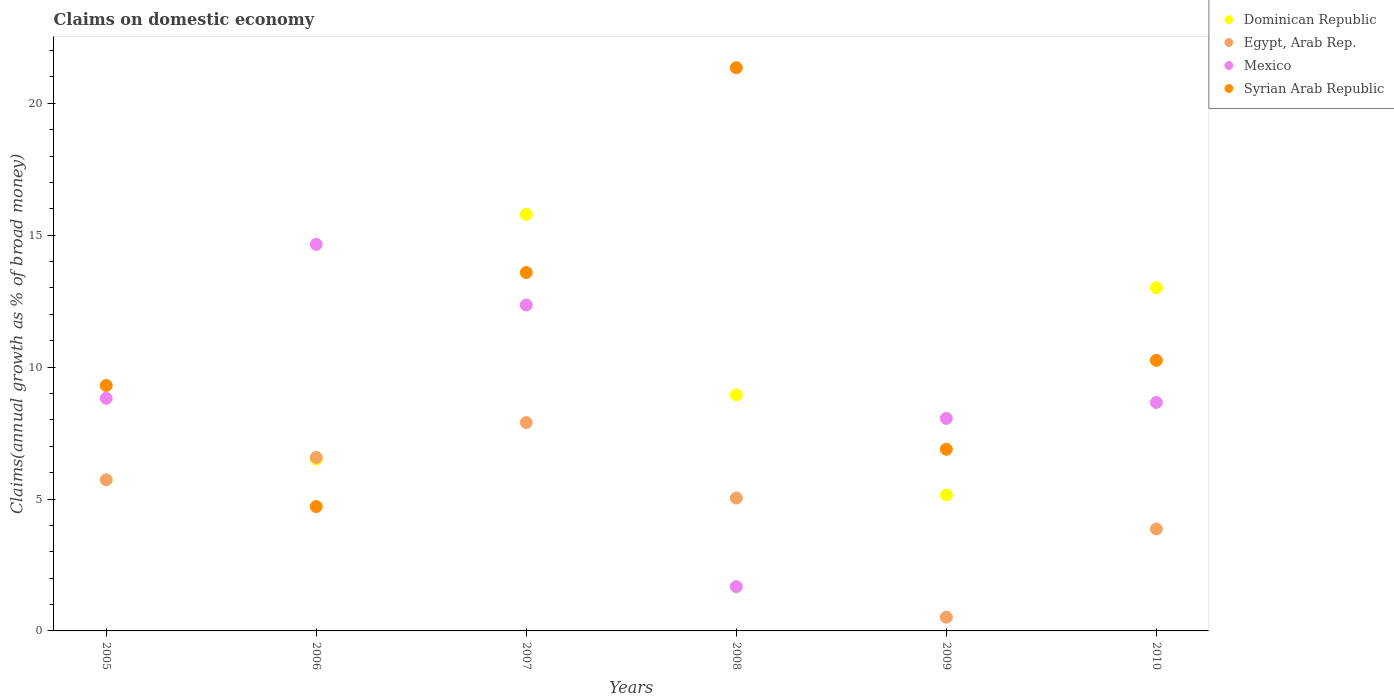What is the percentage of broad money claimed on domestic economy in Syrian Arab Republic in 2009?
Offer a terse response. 6.89. Across all years, what is the maximum percentage of broad money claimed on domestic economy in Egypt, Arab Rep.?
Provide a short and direct response. 7.9. Across all years, what is the minimum percentage of broad money claimed on domestic economy in Syrian Arab Republic?
Your answer should be very brief. 4.71. What is the total percentage of broad money claimed on domestic economy in Syrian Arab Republic in the graph?
Provide a short and direct response. 66.1. What is the difference between the percentage of broad money claimed on domestic economy in Syrian Arab Republic in 2007 and that in 2009?
Provide a short and direct response. 6.7. What is the difference between the percentage of broad money claimed on domestic economy in Syrian Arab Republic in 2006 and the percentage of broad money claimed on domestic economy in Mexico in 2007?
Your answer should be very brief. -7.64. What is the average percentage of broad money claimed on domestic economy in Syrian Arab Republic per year?
Give a very brief answer. 11.02. In the year 2007, what is the difference between the percentage of broad money claimed on domestic economy in Mexico and percentage of broad money claimed on domestic economy in Syrian Arab Republic?
Provide a succinct answer. -1.23. What is the ratio of the percentage of broad money claimed on domestic economy in Syrian Arab Republic in 2007 to that in 2008?
Your answer should be compact. 0.64. Is the percentage of broad money claimed on domestic economy in Mexico in 2005 less than that in 2008?
Give a very brief answer. No. Is the difference between the percentage of broad money claimed on domestic economy in Mexico in 2005 and 2006 greater than the difference between the percentage of broad money claimed on domestic economy in Syrian Arab Republic in 2005 and 2006?
Provide a short and direct response. No. What is the difference between the highest and the second highest percentage of broad money claimed on domestic economy in Mexico?
Make the answer very short. 2.3. What is the difference between the highest and the lowest percentage of broad money claimed on domestic economy in Egypt, Arab Rep.?
Provide a short and direct response. 7.38. In how many years, is the percentage of broad money claimed on domestic economy in Syrian Arab Republic greater than the average percentage of broad money claimed on domestic economy in Syrian Arab Republic taken over all years?
Your answer should be very brief. 2. Are the values on the major ticks of Y-axis written in scientific E-notation?
Offer a terse response. No. Does the graph contain any zero values?
Offer a very short reply. Yes. Does the graph contain grids?
Make the answer very short. No. Where does the legend appear in the graph?
Provide a succinct answer. Top right. What is the title of the graph?
Provide a succinct answer. Claims on domestic economy. What is the label or title of the Y-axis?
Make the answer very short. Claims(annual growth as % of broad money). What is the Claims(annual growth as % of broad money) of Egypt, Arab Rep. in 2005?
Make the answer very short. 5.73. What is the Claims(annual growth as % of broad money) of Mexico in 2005?
Offer a terse response. 8.82. What is the Claims(annual growth as % of broad money) in Syrian Arab Republic in 2005?
Your answer should be very brief. 9.3. What is the Claims(annual growth as % of broad money) in Dominican Republic in 2006?
Your response must be concise. 6.51. What is the Claims(annual growth as % of broad money) of Egypt, Arab Rep. in 2006?
Give a very brief answer. 6.58. What is the Claims(annual growth as % of broad money) of Mexico in 2006?
Provide a succinct answer. 14.65. What is the Claims(annual growth as % of broad money) in Syrian Arab Republic in 2006?
Your answer should be very brief. 4.71. What is the Claims(annual growth as % of broad money) of Dominican Republic in 2007?
Make the answer very short. 15.79. What is the Claims(annual growth as % of broad money) in Egypt, Arab Rep. in 2007?
Provide a short and direct response. 7.9. What is the Claims(annual growth as % of broad money) in Mexico in 2007?
Your answer should be compact. 12.35. What is the Claims(annual growth as % of broad money) in Syrian Arab Republic in 2007?
Provide a short and direct response. 13.59. What is the Claims(annual growth as % of broad money) of Dominican Republic in 2008?
Your answer should be very brief. 8.95. What is the Claims(annual growth as % of broad money) in Egypt, Arab Rep. in 2008?
Provide a succinct answer. 5.04. What is the Claims(annual growth as % of broad money) of Mexico in 2008?
Your response must be concise. 1.68. What is the Claims(annual growth as % of broad money) in Syrian Arab Republic in 2008?
Make the answer very short. 21.35. What is the Claims(annual growth as % of broad money) in Dominican Republic in 2009?
Your response must be concise. 5.15. What is the Claims(annual growth as % of broad money) of Egypt, Arab Rep. in 2009?
Your response must be concise. 0.52. What is the Claims(annual growth as % of broad money) in Mexico in 2009?
Give a very brief answer. 8.06. What is the Claims(annual growth as % of broad money) of Syrian Arab Republic in 2009?
Give a very brief answer. 6.89. What is the Claims(annual growth as % of broad money) in Dominican Republic in 2010?
Provide a short and direct response. 13.01. What is the Claims(annual growth as % of broad money) in Egypt, Arab Rep. in 2010?
Offer a terse response. 3.87. What is the Claims(annual growth as % of broad money) in Mexico in 2010?
Offer a very short reply. 8.66. What is the Claims(annual growth as % of broad money) in Syrian Arab Republic in 2010?
Keep it short and to the point. 10.26. Across all years, what is the maximum Claims(annual growth as % of broad money) in Dominican Republic?
Keep it short and to the point. 15.79. Across all years, what is the maximum Claims(annual growth as % of broad money) in Egypt, Arab Rep.?
Give a very brief answer. 7.9. Across all years, what is the maximum Claims(annual growth as % of broad money) in Mexico?
Give a very brief answer. 14.65. Across all years, what is the maximum Claims(annual growth as % of broad money) of Syrian Arab Republic?
Provide a short and direct response. 21.35. Across all years, what is the minimum Claims(annual growth as % of broad money) of Dominican Republic?
Offer a very short reply. 0. Across all years, what is the minimum Claims(annual growth as % of broad money) in Egypt, Arab Rep.?
Your answer should be very brief. 0.52. Across all years, what is the minimum Claims(annual growth as % of broad money) of Mexico?
Your answer should be very brief. 1.68. Across all years, what is the minimum Claims(annual growth as % of broad money) in Syrian Arab Republic?
Keep it short and to the point. 4.71. What is the total Claims(annual growth as % of broad money) of Dominican Republic in the graph?
Your response must be concise. 49.41. What is the total Claims(annual growth as % of broad money) in Egypt, Arab Rep. in the graph?
Your answer should be compact. 29.63. What is the total Claims(annual growth as % of broad money) of Mexico in the graph?
Offer a very short reply. 54.22. What is the total Claims(annual growth as % of broad money) of Syrian Arab Republic in the graph?
Offer a very short reply. 66.1. What is the difference between the Claims(annual growth as % of broad money) of Egypt, Arab Rep. in 2005 and that in 2006?
Give a very brief answer. -0.85. What is the difference between the Claims(annual growth as % of broad money) of Mexico in 2005 and that in 2006?
Your response must be concise. -5.83. What is the difference between the Claims(annual growth as % of broad money) of Syrian Arab Republic in 2005 and that in 2006?
Provide a short and direct response. 4.59. What is the difference between the Claims(annual growth as % of broad money) in Egypt, Arab Rep. in 2005 and that in 2007?
Offer a terse response. -2.17. What is the difference between the Claims(annual growth as % of broad money) of Mexico in 2005 and that in 2007?
Give a very brief answer. -3.54. What is the difference between the Claims(annual growth as % of broad money) of Syrian Arab Republic in 2005 and that in 2007?
Offer a very short reply. -4.28. What is the difference between the Claims(annual growth as % of broad money) in Egypt, Arab Rep. in 2005 and that in 2008?
Your answer should be very brief. 0.69. What is the difference between the Claims(annual growth as % of broad money) of Mexico in 2005 and that in 2008?
Ensure brevity in your answer.  7.14. What is the difference between the Claims(annual growth as % of broad money) of Syrian Arab Republic in 2005 and that in 2008?
Ensure brevity in your answer.  -12.05. What is the difference between the Claims(annual growth as % of broad money) of Egypt, Arab Rep. in 2005 and that in 2009?
Give a very brief answer. 5.21. What is the difference between the Claims(annual growth as % of broad money) of Mexico in 2005 and that in 2009?
Keep it short and to the point. 0.76. What is the difference between the Claims(annual growth as % of broad money) of Syrian Arab Republic in 2005 and that in 2009?
Your answer should be compact. 2.42. What is the difference between the Claims(annual growth as % of broad money) of Egypt, Arab Rep. in 2005 and that in 2010?
Offer a terse response. 1.86. What is the difference between the Claims(annual growth as % of broad money) in Mexico in 2005 and that in 2010?
Offer a terse response. 0.16. What is the difference between the Claims(annual growth as % of broad money) of Syrian Arab Republic in 2005 and that in 2010?
Make the answer very short. -0.95. What is the difference between the Claims(annual growth as % of broad money) of Dominican Republic in 2006 and that in 2007?
Provide a short and direct response. -9.28. What is the difference between the Claims(annual growth as % of broad money) of Egypt, Arab Rep. in 2006 and that in 2007?
Provide a short and direct response. -1.32. What is the difference between the Claims(annual growth as % of broad money) in Mexico in 2006 and that in 2007?
Make the answer very short. 2.3. What is the difference between the Claims(annual growth as % of broad money) of Syrian Arab Republic in 2006 and that in 2007?
Your answer should be compact. -8.87. What is the difference between the Claims(annual growth as % of broad money) of Dominican Republic in 2006 and that in 2008?
Give a very brief answer. -2.44. What is the difference between the Claims(annual growth as % of broad money) of Egypt, Arab Rep. in 2006 and that in 2008?
Give a very brief answer. 1.54. What is the difference between the Claims(annual growth as % of broad money) of Mexico in 2006 and that in 2008?
Give a very brief answer. 12.97. What is the difference between the Claims(annual growth as % of broad money) of Syrian Arab Republic in 2006 and that in 2008?
Your response must be concise. -16.64. What is the difference between the Claims(annual growth as % of broad money) of Dominican Republic in 2006 and that in 2009?
Your answer should be compact. 1.36. What is the difference between the Claims(annual growth as % of broad money) of Egypt, Arab Rep. in 2006 and that in 2009?
Provide a succinct answer. 6.06. What is the difference between the Claims(annual growth as % of broad money) in Mexico in 2006 and that in 2009?
Ensure brevity in your answer.  6.59. What is the difference between the Claims(annual growth as % of broad money) in Syrian Arab Republic in 2006 and that in 2009?
Provide a succinct answer. -2.17. What is the difference between the Claims(annual growth as % of broad money) in Dominican Republic in 2006 and that in 2010?
Provide a short and direct response. -6.5. What is the difference between the Claims(annual growth as % of broad money) in Egypt, Arab Rep. in 2006 and that in 2010?
Your answer should be compact. 2.71. What is the difference between the Claims(annual growth as % of broad money) of Mexico in 2006 and that in 2010?
Your answer should be compact. 5.99. What is the difference between the Claims(annual growth as % of broad money) of Syrian Arab Republic in 2006 and that in 2010?
Make the answer very short. -5.54. What is the difference between the Claims(annual growth as % of broad money) of Dominican Republic in 2007 and that in 2008?
Offer a terse response. 6.84. What is the difference between the Claims(annual growth as % of broad money) in Egypt, Arab Rep. in 2007 and that in 2008?
Provide a short and direct response. 2.86. What is the difference between the Claims(annual growth as % of broad money) in Mexico in 2007 and that in 2008?
Your answer should be compact. 10.67. What is the difference between the Claims(annual growth as % of broad money) of Syrian Arab Republic in 2007 and that in 2008?
Provide a succinct answer. -7.76. What is the difference between the Claims(annual growth as % of broad money) in Dominican Republic in 2007 and that in 2009?
Offer a terse response. 10.64. What is the difference between the Claims(annual growth as % of broad money) in Egypt, Arab Rep. in 2007 and that in 2009?
Offer a terse response. 7.38. What is the difference between the Claims(annual growth as % of broad money) in Mexico in 2007 and that in 2009?
Your response must be concise. 4.3. What is the difference between the Claims(annual growth as % of broad money) of Syrian Arab Republic in 2007 and that in 2009?
Keep it short and to the point. 6.7. What is the difference between the Claims(annual growth as % of broad money) in Dominican Republic in 2007 and that in 2010?
Provide a succinct answer. 2.78. What is the difference between the Claims(annual growth as % of broad money) in Egypt, Arab Rep. in 2007 and that in 2010?
Offer a terse response. 4.03. What is the difference between the Claims(annual growth as % of broad money) in Mexico in 2007 and that in 2010?
Give a very brief answer. 3.69. What is the difference between the Claims(annual growth as % of broad money) of Syrian Arab Republic in 2007 and that in 2010?
Your answer should be very brief. 3.33. What is the difference between the Claims(annual growth as % of broad money) of Dominican Republic in 2008 and that in 2009?
Ensure brevity in your answer.  3.79. What is the difference between the Claims(annual growth as % of broad money) of Egypt, Arab Rep. in 2008 and that in 2009?
Ensure brevity in your answer.  4.52. What is the difference between the Claims(annual growth as % of broad money) in Mexico in 2008 and that in 2009?
Provide a short and direct response. -6.38. What is the difference between the Claims(annual growth as % of broad money) in Syrian Arab Republic in 2008 and that in 2009?
Your response must be concise. 14.46. What is the difference between the Claims(annual growth as % of broad money) in Dominican Republic in 2008 and that in 2010?
Keep it short and to the point. -4.06. What is the difference between the Claims(annual growth as % of broad money) of Egypt, Arab Rep. in 2008 and that in 2010?
Offer a very short reply. 1.17. What is the difference between the Claims(annual growth as % of broad money) of Mexico in 2008 and that in 2010?
Your answer should be compact. -6.98. What is the difference between the Claims(annual growth as % of broad money) in Syrian Arab Republic in 2008 and that in 2010?
Keep it short and to the point. 11.09. What is the difference between the Claims(annual growth as % of broad money) in Dominican Republic in 2009 and that in 2010?
Offer a terse response. -7.86. What is the difference between the Claims(annual growth as % of broad money) of Egypt, Arab Rep. in 2009 and that in 2010?
Your answer should be very brief. -3.34. What is the difference between the Claims(annual growth as % of broad money) of Mexico in 2009 and that in 2010?
Your answer should be compact. -0.6. What is the difference between the Claims(annual growth as % of broad money) of Syrian Arab Republic in 2009 and that in 2010?
Your answer should be very brief. -3.37. What is the difference between the Claims(annual growth as % of broad money) of Egypt, Arab Rep. in 2005 and the Claims(annual growth as % of broad money) of Mexico in 2006?
Your answer should be compact. -8.92. What is the difference between the Claims(annual growth as % of broad money) in Mexico in 2005 and the Claims(annual growth as % of broad money) in Syrian Arab Republic in 2006?
Provide a succinct answer. 4.11. What is the difference between the Claims(annual growth as % of broad money) in Egypt, Arab Rep. in 2005 and the Claims(annual growth as % of broad money) in Mexico in 2007?
Give a very brief answer. -6.62. What is the difference between the Claims(annual growth as % of broad money) of Egypt, Arab Rep. in 2005 and the Claims(annual growth as % of broad money) of Syrian Arab Republic in 2007?
Keep it short and to the point. -7.86. What is the difference between the Claims(annual growth as % of broad money) of Mexico in 2005 and the Claims(annual growth as % of broad money) of Syrian Arab Republic in 2007?
Provide a succinct answer. -4.77. What is the difference between the Claims(annual growth as % of broad money) in Egypt, Arab Rep. in 2005 and the Claims(annual growth as % of broad money) in Mexico in 2008?
Your answer should be very brief. 4.05. What is the difference between the Claims(annual growth as % of broad money) of Egypt, Arab Rep. in 2005 and the Claims(annual growth as % of broad money) of Syrian Arab Republic in 2008?
Your answer should be compact. -15.62. What is the difference between the Claims(annual growth as % of broad money) of Mexico in 2005 and the Claims(annual growth as % of broad money) of Syrian Arab Republic in 2008?
Ensure brevity in your answer.  -12.53. What is the difference between the Claims(annual growth as % of broad money) in Egypt, Arab Rep. in 2005 and the Claims(annual growth as % of broad money) in Mexico in 2009?
Make the answer very short. -2.33. What is the difference between the Claims(annual growth as % of broad money) of Egypt, Arab Rep. in 2005 and the Claims(annual growth as % of broad money) of Syrian Arab Republic in 2009?
Give a very brief answer. -1.16. What is the difference between the Claims(annual growth as % of broad money) of Mexico in 2005 and the Claims(annual growth as % of broad money) of Syrian Arab Republic in 2009?
Ensure brevity in your answer.  1.93. What is the difference between the Claims(annual growth as % of broad money) of Egypt, Arab Rep. in 2005 and the Claims(annual growth as % of broad money) of Mexico in 2010?
Offer a very short reply. -2.93. What is the difference between the Claims(annual growth as % of broad money) in Egypt, Arab Rep. in 2005 and the Claims(annual growth as % of broad money) in Syrian Arab Republic in 2010?
Offer a terse response. -4.53. What is the difference between the Claims(annual growth as % of broad money) in Mexico in 2005 and the Claims(annual growth as % of broad money) in Syrian Arab Republic in 2010?
Your answer should be compact. -1.44. What is the difference between the Claims(annual growth as % of broad money) in Dominican Republic in 2006 and the Claims(annual growth as % of broad money) in Egypt, Arab Rep. in 2007?
Ensure brevity in your answer.  -1.39. What is the difference between the Claims(annual growth as % of broad money) in Dominican Republic in 2006 and the Claims(annual growth as % of broad money) in Mexico in 2007?
Offer a very short reply. -5.84. What is the difference between the Claims(annual growth as % of broad money) of Dominican Republic in 2006 and the Claims(annual growth as % of broad money) of Syrian Arab Republic in 2007?
Provide a succinct answer. -7.08. What is the difference between the Claims(annual growth as % of broad money) in Egypt, Arab Rep. in 2006 and the Claims(annual growth as % of broad money) in Mexico in 2007?
Your answer should be compact. -5.78. What is the difference between the Claims(annual growth as % of broad money) of Egypt, Arab Rep. in 2006 and the Claims(annual growth as % of broad money) of Syrian Arab Republic in 2007?
Your response must be concise. -7.01. What is the difference between the Claims(annual growth as % of broad money) of Mexico in 2006 and the Claims(annual growth as % of broad money) of Syrian Arab Republic in 2007?
Ensure brevity in your answer.  1.07. What is the difference between the Claims(annual growth as % of broad money) in Dominican Republic in 2006 and the Claims(annual growth as % of broad money) in Egypt, Arab Rep. in 2008?
Give a very brief answer. 1.47. What is the difference between the Claims(annual growth as % of broad money) in Dominican Republic in 2006 and the Claims(annual growth as % of broad money) in Mexico in 2008?
Your answer should be compact. 4.83. What is the difference between the Claims(annual growth as % of broad money) of Dominican Republic in 2006 and the Claims(annual growth as % of broad money) of Syrian Arab Republic in 2008?
Keep it short and to the point. -14.84. What is the difference between the Claims(annual growth as % of broad money) in Egypt, Arab Rep. in 2006 and the Claims(annual growth as % of broad money) in Mexico in 2008?
Make the answer very short. 4.9. What is the difference between the Claims(annual growth as % of broad money) in Egypt, Arab Rep. in 2006 and the Claims(annual growth as % of broad money) in Syrian Arab Republic in 2008?
Offer a terse response. -14.77. What is the difference between the Claims(annual growth as % of broad money) in Mexico in 2006 and the Claims(annual growth as % of broad money) in Syrian Arab Republic in 2008?
Ensure brevity in your answer.  -6.7. What is the difference between the Claims(annual growth as % of broad money) in Dominican Republic in 2006 and the Claims(annual growth as % of broad money) in Egypt, Arab Rep. in 2009?
Give a very brief answer. 5.99. What is the difference between the Claims(annual growth as % of broad money) of Dominican Republic in 2006 and the Claims(annual growth as % of broad money) of Mexico in 2009?
Give a very brief answer. -1.55. What is the difference between the Claims(annual growth as % of broad money) of Dominican Republic in 2006 and the Claims(annual growth as % of broad money) of Syrian Arab Republic in 2009?
Your answer should be very brief. -0.38. What is the difference between the Claims(annual growth as % of broad money) in Egypt, Arab Rep. in 2006 and the Claims(annual growth as % of broad money) in Mexico in 2009?
Provide a succinct answer. -1.48. What is the difference between the Claims(annual growth as % of broad money) in Egypt, Arab Rep. in 2006 and the Claims(annual growth as % of broad money) in Syrian Arab Republic in 2009?
Offer a terse response. -0.31. What is the difference between the Claims(annual growth as % of broad money) of Mexico in 2006 and the Claims(annual growth as % of broad money) of Syrian Arab Republic in 2009?
Your answer should be compact. 7.77. What is the difference between the Claims(annual growth as % of broad money) in Dominican Republic in 2006 and the Claims(annual growth as % of broad money) in Egypt, Arab Rep. in 2010?
Ensure brevity in your answer.  2.64. What is the difference between the Claims(annual growth as % of broad money) of Dominican Republic in 2006 and the Claims(annual growth as % of broad money) of Mexico in 2010?
Provide a short and direct response. -2.15. What is the difference between the Claims(annual growth as % of broad money) of Dominican Republic in 2006 and the Claims(annual growth as % of broad money) of Syrian Arab Republic in 2010?
Your answer should be very brief. -3.75. What is the difference between the Claims(annual growth as % of broad money) of Egypt, Arab Rep. in 2006 and the Claims(annual growth as % of broad money) of Mexico in 2010?
Your response must be concise. -2.08. What is the difference between the Claims(annual growth as % of broad money) in Egypt, Arab Rep. in 2006 and the Claims(annual growth as % of broad money) in Syrian Arab Republic in 2010?
Offer a terse response. -3.68. What is the difference between the Claims(annual growth as % of broad money) of Mexico in 2006 and the Claims(annual growth as % of broad money) of Syrian Arab Republic in 2010?
Ensure brevity in your answer.  4.4. What is the difference between the Claims(annual growth as % of broad money) of Dominican Republic in 2007 and the Claims(annual growth as % of broad money) of Egypt, Arab Rep. in 2008?
Your response must be concise. 10.75. What is the difference between the Claims(annual growth as % of broad money) in Dominican Republic in 2007 and the Claims(annual growth as % of broad money) in Mexico in 2008?
Your answer should be compact. 14.11. What is the difference between the Claims(annual growth as % of broad money) of Dominican Republic in 2007 and the Claims(annual growth as % of broad money) of Syrian Arab Republic in 2008?
Give a very brief answer. -5.56. What is the difference between the Claims(annual growth as % of broad money) of Egypt, Arab Rep. in 2007 and the Claims(annual growth as % of broad money) of Mexico in 2008?
Offer a terse response. 6.22. What is the difference between the Claims(annual growth as % of broad money) in Egypt, Arab Rep. in 2007 and the Claims(annual growth as % of broad money) in Syrian Arab Republic in 2008?
Ensure brevity in your answer.  -13.45. What is the difference between the Claims(annual growth as % of broad money) in Mexico in 2007 and the Claims(annual growth as % of broad money) in Syrian Arab Republic in 2008?
Offer a very short reply. -9. What is the difference between the Claims(annual growth as % of broad money) in Dominican Republic in 2007 and the Claims(annual growth as % of broad money) in Egypt, Arab Rep. in 2009?
Your answer should be very brief. 15.27. What is the difference between the Claims(annual growth as % of broad money) of Dominican Republic in 2007 and the Claims(annual growth as % of broad money) of Mexico in 2009?
Your answer should be very brief. 7.73. What is the difference between the Claims(annual growth as % of broad money) of Dominican Republic in 2007 and the Claims(annual growth as % of broad money) of Syrian Arab Republic in 2009?
Provide a short and direct response. 8.91. What is the difference between the Claims(annual growth as % of broad money) of Egypt, Arab Rep. in 2007 and the Claims(annual growth as % of broad money) of Mexico in 2009?
Offer a terse response. -0.16. What is the difference between the Claims(annual growth as % of broad money) in Egypt, Arab Rep. in 2007 and the Claims(annual growth as % of broad money) in Syrian Arab Republic in 2009?
Provide a short and direct response. 1.01. What is the difference between the Claims(annual growth as % of broad money) in Mexico in 2007 and the Claims(annual growth as % of broad money) in Syrian Arab Republic in 2009?
Keep it short and to the point. 5.47. What is the difference between the Claims(annual growth as % of broad money) of Dominican Republic in 2007 and the Claims(annual growth as % of broad money) of Egypt, Arab Rep. in 2010?
Your answer should be compact. 11.93. What is the difference between the Claims(annual growth as % of broad money) of Dominican Republic in 2007 and the Claims(annual growth as % of broad money) of Mexico in 2010?
Offer a very short reply. 7.13. What is the difference between the Claims(annual growth as % of broad money) in Dominican Republic in 2007 and the Claims(annual growth as % of broad money) in Syrian Arab Republic in 2010?
Your answer should be compact. 5.54. What is the difference between the Claims(annual growth as % of broad money) of Egypt, Arab Rep. in 2007 and the Claims(annual growth as % of broad money) of Mexico in 2010?
Keep it short and to the point. -0.76. What is the difference between the Claims(annual growth as % of broad money) in Egypt, Arab Rep. in 2007 and the Claims(annual growth as % of broad money) in Syrian Arab Republic in 2010?
Provide a short and direct response. -2.36. What is the difference between the Claims(annual growth as % of broad money) in Mexico in 2007 and the Claims(annual growth as % of broad money) in Syrian Arab Republic in 2010?
Give a very brief answer. 2.1. What is the difference between the Claims(annual growth as % of broad money) in Dominican Republic in 2008 and the Claims(annual growth as % of broad money) in Egypt, Arab Rep. in 2009?
Provide a succinct answer. 8.43. What is the difference between the Claims(annual growth as % of broad money) in Dominican Republic in 2008 and the Claims(annual growth as % of broad money) in Mexico in 2009?
Provide a short and direct response. 0.89. What is the difference between the Claims(annual growth as % of broad money) in Dominican Republic in 2008 and the Claims(annual growth as % of broad money) in Syrian Arab Republic in 2009?
Offer a terse response. 2.06. What is the difference between the Claims(annual growth as % of broad money) of Egypt, Arab Rep. in 2008 and the Claims(annual growth as % of broad money) of Mexico in 2009?
Provide a succinct answer. -3.02. What is the difference between the Claims(annual growth as % of broad money) of Egypt, Arab Rep. in 2008 and the Claims(annual growth as % of broad money) of Syrian Arab Republic in 2009?
Offer a terse response. -1.85. What is the difference between the Claims(annual growth as % of broad money) in Mexico in 2008 and the Claims(annual growth as % of broad money) in Syrian Arab Republic in 2009?
Make the answer very short. -5.21. What is the difference between the Claims(annual growth as % of broad money) in Dominican Republic in 2008 and the Claims(annual growth as % of broad money) in Egypt, Arab Rep. in 2010?
Your answer should be very brief. 5.08. What is the difference between the Claims(annual growth as % of broad money) in Dominican Republic in 2008 and the Claims(annual growth as % of broad money) in Mexico in 2010?
Ensure brevity in your answer.  0.29. What is the difference between the Claims(annual growth as % of broad money) of Dominican Republic in 2008 and the Claims(annual growth as % of broad money) of Syrian Arab Republic in 2010?
Your response must be concise. -1.31. What is the difference between the Claims(annual growth as % of broad money) in Egypt, Arab Rep. in 2008 and the Claims(annual growth as % of broad money) in Mexico in 2010?
Your response must be concise. -3.62. What is the difference between the Claims(annual growth as % of broad money) of Egypt, Arab Rep. in 2008 and the Claims(annual growth as % of broad money) of Syrian Arab Republic in 2010?
Provide a succinct answer. -5.22. What is the difference between the Claims(annual growth as % of broad money) in Mexico in 2008 and the Claims(annual growth as % of broad money) in Syrian Arab Republic in 2010?
Offer a terse response. -8.58. What is the difference between the Claims(annual growth as % of broad money) in Dominican Republic in 2009 and the Claims(annual growth as % of broad money) in Egypt, Arab Rep. in 2010?
Your answer should be very brief. 1.29. What is the difference between the Claims(annual growth as % of broad money) of Dominican Republic in 2009 and the Claims(annual growth as % of broad money) of Mexico in 2010?
Offer a terse response. -3.51. What is the difference between the Claims(annual growth as % of broad money) in Dominican Republic in 2009 and the Claims(annual growth as % of broad money) in Syrian Arab Republic in 2010?
Offer a terse response. -5.1. What is the difference between the Claims(annual growth as % of broad money) in Egypt, Arab Rep. in 2009 and the Claims(annual growth as % of broad money) in Mexico in 2010?
Your answer should be very brief. -8.14. What is the difference between the Claims(annual growth as % of broad money) in Egypt, Arab Rep. in 2009 and the Claims(annual growth as % of broad money) in Syrian Arab Republic in 2010?
Offer a terse response. -9.74. What is the difference between the Claims(annual growth as % of broad money) in Mexico in 2009 and the Claims(annual growth as % of broad money) in Syrian Arab Republic in 2010?
Give a very brief answer. -2.2. What is the average Claims(annual growth as % of broad money) of Dominican Republic per year?
Your answer should be very brief. 8.24. What is the average Claims(annual growth as % of broad money) of Egypt, Arab Rep. per year?
Your answer should be very brief. 4.94. What is the average Claims(annual growth as % of broad money) in Mexico per year?
Your response must be concise. 9.04. What is the average Claims(annual growth as % of broad money) in Syrian Arab Republic per year?
Offer a very short reply. 11.02. In the year 2005, what is the difference between the Claims(annual growth as % of broad money) in Egypt, Arab Rep. and Claims(annual growth as % of broad money) in Mexico?
Offer a very short reply. -3.09. In the year 2005, what is the difference between the Claims(annual growth as % of broad money) in Egypt, Arab Rep. and Claims(annual growth as % of broad money) in Syrian Arab Republic?
Your response must be concise. -3.57. In the year 2005, what is the difference between the Claims(annual growth as % of broad money) of Mexico and Claims(annual growth as % of broad money) of Syrian Arab Republic?
Give a very brief answer. -0.49. In the year 2006, what is the difference between the Claims(annual growth as % of broad money) in Dominican Republic and Claims(annual growth as % of broad money) in Egypt, Arab Rep.?
Your answer should be compact. -0.07. In the year 2006, what is the difference between the Claims(annual growth as % of broad money) in Dominican Republic and Claims(annual growth as % of broad money) in Mexico?
Make the answer very short. -8.14. In the year 2006, what is the difference between the Claims(annual growth as % of broad money) of Dominican Republic and Claims(annual growth as % of broad money) of Syrian Arab Republic?
Make the answer very short. 1.8. In the year 2006, what is the difference between the Claims(annual growth as % of broad money) of Egypt, Arab Rep. and Claims(annual growth as % of broad money) of Mexico?
Your answer should be compact. -8.07. In the year 2006, what is the difference between the Claims(annual growth as % of broad money) of Egypt, Arab Rep. and Claims(annual growth as % of broad money) of Syrian Arab Republic?
Give a very brief answer. 1.86. In the year 2006, what is the difference between the Claims(annual growth as % of broad money) of Mexico and Claims(annual growth as % of broad money) of Syrian Arab Republic?
Offer a terse response. 9.94. In the year 2007, what is the difference between the Claims(annual growth as % of broad money) of Dominican Republic and Claims(annual growth as % of broad money) of Egypt, Arab Rep.?
Your answer should be compact. 7.89. In the year 2007, what is the difference between the Claims(annual growth as % of broad money) in Dominican Republic and Claims(annual growth as % of broad money) in Mexico?
Offer a very short reply. 3.44. In the year 2007, what is the difference between the Claims(annual growth as % of broad money) of Dominican Republic and Claims(annual growth as % of broad money) of Syrian Arab Republic?
Keep it short and to the point. 2.21. In the year 2007, what is the difference between the Claims(annual growth as % of broad money) of Egypt, Arab Rep. and Claims(annual growth as % of broad money) of Mexico?
Provide a short and direct response. -4.46. In the year 2007, what is the difference between the Claims(annual growth as % of broad money) in Egypt, Arab Rep. and Claims(annual growth as % of broad money) in Syrian Arab Republic?
Offer a terse response. -5.69. In the year 2007, what is the difference between the Claims(annual growth as % of broad money) of Mexico and Claims(annual growth as % of broad money) of Syrian Arab Republic?
Offer a terse response. -1.23. In the year 2008, what is the difference between the Claims(annual growth as % of broad money) of Dominican Republic and Claims(annual growth as % of broad money) of Egypt, Arab Rep.?
Ensure brevity in your answer.  3.91. In the year 2008, what is the difference between the Claims(annual growth as % of broad money) in Dominican Republic and Claims(annual growth as % of broad money) in Mexico?
Your response must be concise. 7.27. In the year 2008, what is the difference between the Claims(annual growth as % of broad money) of Dominican Republic and Claims(annual growth as % of broad money) of Syrian Arab Republic?
Offer a terse response. -12.4. In the year 2008, what is the difference between the Claims(annual growth as % of broad money) in Egypt, Arab Rep. and Claims(annual growth as % of broad money) in Mexico?
Give a very brief answer. 3.36. In the year 2008, what is the difference between the Claims(annual growth as % of broad money) in Egypt, Arab Rep. and Claims(annual growth as % of broad money) in Syrian Arab Republic?
Give a very brief answer. -16.31. In the year 2008, what is the difference between the Claims(annual growth as % of broad money) of Mexico and Claims(annual growth as % of broad money) of Syrian Arab Republic?
Your answer should be very brief. -19.67. In the year 2009, what is the difference between the Claims(annual growth as % of broad money) of Dominican Republic and Claims(annual growth as % of broad money) of Egypt, Arab Rep.?
Your answer should be compact. 4.63. In the year 2009, what is the difference between the Claims(annual growth as % of broad money) in Dominican Republic and Claims(annual growth as % of broad money) in Mexico?
Provide a short and direct response. -2.9. In the year 2009, what is the difference between the Claims(annual growth as % of broad money) of Dominican Republic and Claims(annual growth as % of broad money) of Syrian Arab Republic?
Provide a succinct answer. -1.73. In the year 2009, what is the difference between the Claims(annual growth as % of broad money) in Egypt, Arab Rep. and Claims(annual growth as % of broad money) in Mexico?
Make the answer very short. -7.54. In the year 2009, what is the difference between the Claims(annual growth as % of broad money) of Egypt, Arab Rep. and Claims(annual growth as % of broad money) of Syrian Arab Republic?
Offer a terse response. -6.37. In the year 2009, what is the difference between the Claims(annual growth as % of broad money) of Mexico and Claims(annual growth as % of broad money) of Syrian Arab Republic?
Provide a short and direct response. 1.17. In the year 2010, what is the difference between the Claims(annual growth as % of broad money) in Dominican Republic and Claims(annual growth as % of broad money) in Egypt, Arab Rep.?
Give a very brief answer. 9.15. In the year 2010, what is the difference between the Claims(annual growth as % of broad money) in Dominican Republic and Claims(annual growth as % of broad money) in Mexico?
Your answer should be very brief. 4.35. In the year 2010, what is the difference between the Claims(annual growth as % of broad money) in Dominican Republic and Claims(annual growth as % of broad money) in Syrian Arab Republic?
Ensure brevity in your answer.  2.75. In the year 2010, what is the difference between the Claims(annual growth as % of broad money) of Egypt, Arab Rep. and Claims(annual growth as % of broad money) of Mexico?
Your answer should be compact. -4.79. In the year 2010, what is the difference between the Claims(annual growth as % of broad money) of Egypt, Arab Rep. and Claims(annual growth as % of broad money) of Syrian Arab Republic?
Make the answer very short. -6.39. In the year 2010, what is the difference between the Claims(annual growth as % of broad money) of Mexico and Claims(annual growth as % of broad money) of Syrian Arab Republic?
Provide a succinct answer. -1.6. What is the ratio of the Claims(annual growth as % of broad money) of Egypt, Arab Rep. in 2005 to that in 2006?
Offer a terse response. 0.87. What is the ratio of the Claims(annual growth as % of broad money) of Mexico in 2005 to that in 2006?
Provide a succinct answer. 0.6. What is the ratio of the Claims(annual growth as % of broad money) of Syrian Arab Republic in 2005 to that in 2006?
Give a very brief answer. 1.97. What is the ratio of the Claims(annual growth as % of broad money) in Egypt, Arab Rep. in 2005 to that in 2007?
Provide a succinct answer. 0.73. What is the ratio of the Claims(annual growth as % of broad money) in Mexico in 2005 to that in 2007?
Your answer should be compact. 0.71. What is the ratio of the Claims(annual growth as % of broad money) of Syrian Arab Republic in 2005 to that in 2007?
Your response must be concise. 0.68. What is the ratio of the Claims(annual growth as % of broad money) of Egypt, Arab Rep. in 2005 to that in 2008?
Keep it short and to the point. 1.14. What is the ratio of the Claims(annual growth as % of broad money) in Mexico in 2005 to that in 2008?
Your answer should be compact. 5.25. What is the ratio of the Claims(annual growth as % of broad money) in Syrian Arab Republic in 2005 to that in 2008?
Your answer should be very brief. 0.44. What is the ratio of the Claims(annual growth as % of broad money) of Egypt, Arab Rep. in 2005 to that in 2009?
Provide a short and direct response. 11.01. What is the ratio of the Claims(annual growth as % of broad money) in Mexico in 2005 to that in 2009?
Your response must be concise. 1.09. What is the ratio of the Claims(annual growth as % of broad money) of Syrian Arab Republic in 2005 to that in 2009?
Your response must be concise. 1.35. What is the ratio of the Claims(annual growth as % of broad money) of Egypt, Arab Rep. in 2005 to that in 2010?
Provide a short and direct response. 1.48. What is the ratio of the Claims(annual growth as % of broad money) of Mexico in 2005 to that in 2010?
Keep it short and to the point. 1.02. What is the ratio of the Claims(annual growth as % of broad money) of Syrian Arab Republic in 2005 to that in 2010?
Offer a terse response. 0.91. What is the ratio of the Claims(annual growth as % of broad money) of Dominican Republic in 2006 to that in 2007?
Ensure brevity in your answer.  0.41. What is the ratio of the Claims(annual growth as % of broad money) of Egypt, Arab Rep. in 2006 to that in 2007?
Your answer should be compact. 0.83. What is the ratio of the Claims(annual growth as % of broad money) of Mexico in 2006 to that in 2007?
Give a very brief answer. 1.19. What is the ratio of the Claims(annual growth as % of broad money) of Syrian Arab Republic in 2006 to that in 2007?
Provide a short and direct response. 0.35. What is the ratio of the Claims(annual growth as % of broad money) in Dominican Republic in 2006 to that in 2008?
Give a very brief answer. 0.73. What is the ratio of the Claims(annual growth as % of broad money) in Egypt, Arab Rep. in 2006 to that in 2008?
Your answer should be very brief. 1.31. What is the ratio of the Claims(annual growth as % of broad money) in Mexico in 2006 to that in 2008?
Ensure brevity in your answer.  8.72. What is the ratio of the Claims(annual growth as % of broad money) of Syrian Arab Republic in 2006 to that in 2008?
Make the answer very short. 0.22. What is the ratio of the Claims(annual growth as % of broad money) in Dominican Republic in 2006 to that in 2009?
Make the answer very short. 1.26. What is the ratio of the Claims(annual growth as % of broad money) of Egypt, Arab Rep. in 2006 to that in 2009?
Your answer should be very brief. 12.63. What is the ratio of the Claims(annual growth as % of broad money) in Mexico in 2006 to that in 2009?
Give a very brief answer. 1.82. What is the ratio of the Claims(annual growth as % of broad money) of Syrian Arab Republic in 2006 to that in 2009?
Your answer should be very brief. 0.68. What is the ratio of the Claims(annual growth as % of broad money) in Dominican Republic in 2006 to that in 2010?
Provide a succinct answer. 0.5. What is the ratio of the Claims(annual growth as % of broad money) of Egypt, Arab Rep. in 2006 to that in 2010?
Keep it short and to the point. 1.7. What is the ratio of the Claims(annual growth as % of broad money) of Mexico in 2006 to that in 2010?
Ensure brevity in your answer.  1.69. What is the ratio of the Claims(annual growth as % of broad money) of Syrian Arab Republic in 2006 to that in 2010?
Offer a very short reply. 0.46. What is the ratio of the Claims(annual growth as % of broad money) in Dominican Republic in 2007 to that in 2008?
Offer a very short reply. 1.76. What is the ratio of the Claims(annual growth as % of broad money) of Egypt, Arab Rep. in 2007 to that in 2008?
Ensure brevity in your answer.  1.57. What is the ratio of the Claims(annual growth as % of broad money) in Mexico in 2007 to that in 2008?
Your answer should be very brief. 7.35. What is the ratio of the Claims(annual growth as % of broad money) of Syrian Arab Republic in 2007 to that in 2008?
Provide a succinct answer. 0.64. What is the ratio of the Claims(annual growth as % of broad money) in Dominican Republic in 2007 to that in 2009?
Make the answer very short. 3.06. What is the ratio of the Claims(annual growth as % of broad money) of Egypt, Arab Rep. in 2007 to that in 2009?
Ensure brevity in your answer.  15.17. What is the ratio of the Claims(annual growth as % of broad money) of Mexico in 2007 to that in 2009?
Your response must be concise. 1.53. What is the ratio of the Claims(annual growth as % of broad money) in Syrian Arab Republic in 2007 to that in 2009?
Keep it short and to the point. 1.97. What is the ratio of the Claims(annual growth as % of broad money) in Dominican Republic in 2007 to that in 2010?
Keep it short and to the point. 1.21. What is the ratio of the Claims(annual growth as % of broad money) of Egypt, Arab Rep. in 2007 to that in 2010?
Offer a terse response. 2.04. What is the ratio of the Claims(annual growth as % of broad money) of Mexico in 2007 to that in 2010?
Provide a succinct answer. 1.43. What is the ratio of the Claims(annual growth as % of broad money) of Syrian Arab Republic in 2007 to that in 2010?
Make the answer very short. 1.32. What is the ratio of the Claims(annual growth as % of broad money) in Dominican Republic in 2008 to that in 2009?
Provide a short and direct response. 1.74. What is the ratio of the Claims(annual growth as % of broad money) of Egypt, Arab Rep. in 2008 to that in 2009?
Ensure brevity in your answer.  9.68. What is the ratio of the Claims(annual growth as % of broad money) in Mexico in 2008 to that in 2009?
Keep it short and to the point. 0.21. What is the ratio of the Claims(annual growth as % of broad money) of Syrian Arab Republic in 2008 to that in 2009?
Your response must be concise. 3.1. What is the ratio of the Claims(annual growth as % of broad money) in Dominican Republic in 2008 to that in 2010?
Make the answer very short. 0.69. What is the ratio of the Claims(annual growth as % of broad money) in Egypt, Arab Rep. in 2008 to that in 2010?
Your response must be concise. 1.3. What is the ratio of the Claims(annual growth as % of broad money) in Mexico in 2008 to that in 2010?
Make the answer very short. 0.19. What is the ratio of the Claims(annual growth as % of broad money) of Syrian Arab Republic in 2008 to that in 2010?
Give a very brief answer. 2.08. What is the ratio of the Claims(annual growth as % of broad money) in Dominican Republic in 2009 to that in 2010?
Keep it short and to the point. 0.4. What is the ratio of the Claims(annual growth as % of broad money) of Egypt, Arab Rep. in 2009 to that in 2010?
Provide a succinct answer. 0.13. What is the ratio of the Claims(annual growth as % of broad money) of Mexico in 2009 to that in 2010?
Make the answer very short. 0.93. What is the ratio of the Claims(annual growth as % of broad money) of Syrian Arab Republic in 2009 to that in 2010?
Make the answer very short. 0.67. What is the difference between the highest and the second highest Claims(annual growth as % of broad money) of Dominican Republic?
Your answer should be compact. 2.78. What is the difference between the highest and the second highest Claims(annual growth as % of broad money) of Egypt, Arab Rep.?
Ensure brevity in your answer.  1.32. What is the difference between the highest and the second highest Claims(annual growth as % of broad money) of Mexico?
Provide a succinct answer. 2.3. What is the difference between the highest and the second highest Claims(annual growth as % of broad money) of Syrian Arab Republic?
Offer a very short reply. 7.76. What is the difference between the highest and the lowest Claims(annual growth as % of broad money) in Dominican Republic?
Provide a short and direct response. 15.79. What is the difference between the highest and the lowest Claims(annual growth as % of broad money) of Egypt, Arab Rep.?
Provide a short and direct response. 7.38. What is the difference between the highest and the lowest Claims(annual growth as % of broad money) in Mexico?
Your response must be concise. 12.97. What is the difference between the highest and the lowest Claims(annual growth as % of broad money) in Syrian Arab Republic?
Offer a terse response. 16.64. 